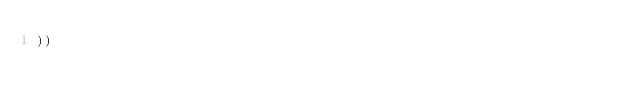<code> <loc_0><loc_0><loc_500><loc_500><_Lisp_>))
</code> 